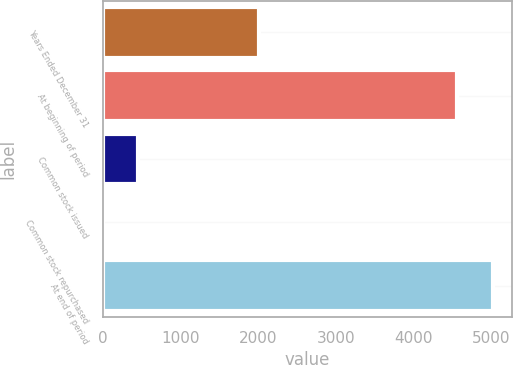<chart> <loc_0><loc_0><loc_500><loc_500><bar_chart><fcel>Years Ended December 31<fcel>At beginning of period<fcel>Common stock issued<fcel>Common stock repurchased<fcel>At end of period<nl><fcel>2010<fcel>4560<fcel>460.6<fcel>2<fcel>5018.6<nl></chart> 